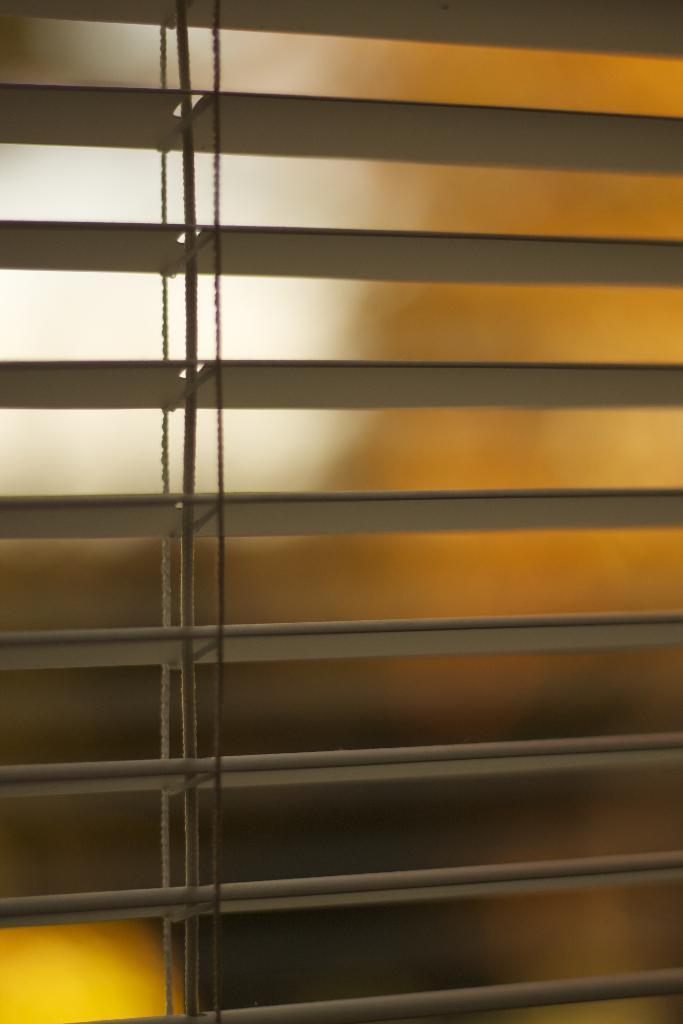How would you summarize this image in a sentence or two? In this image we can see blinds and thread. 